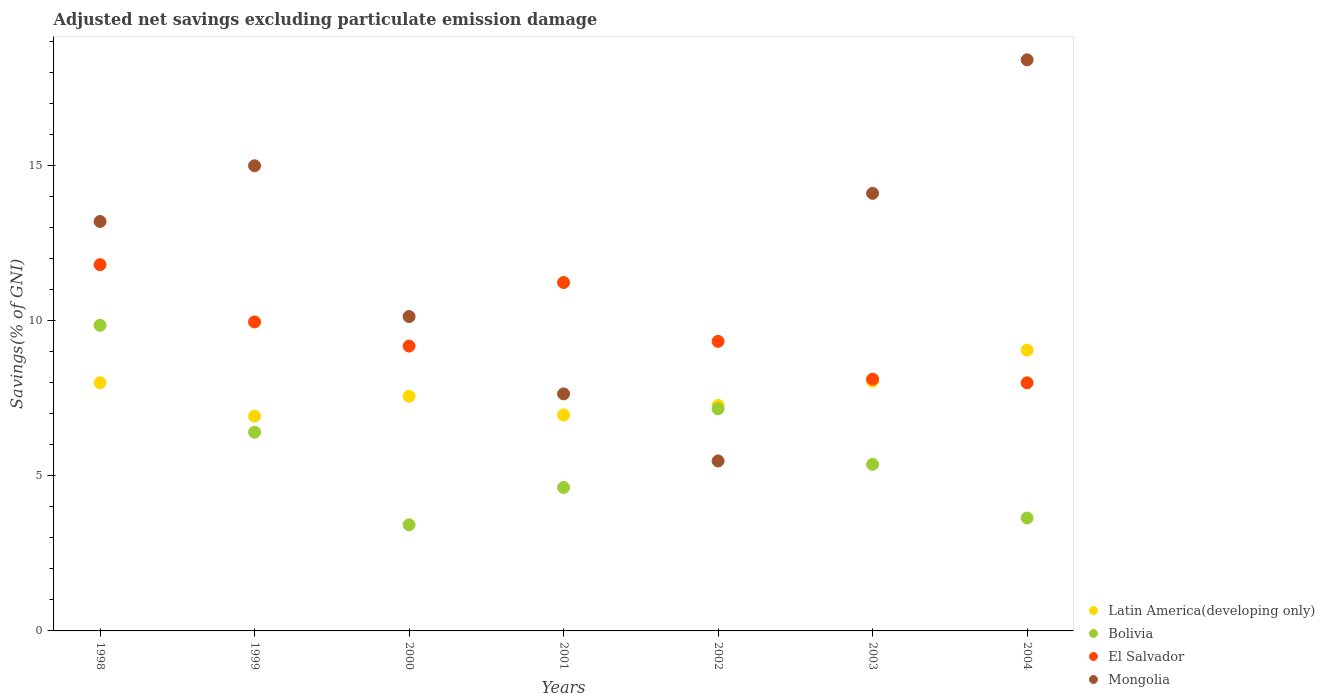How many different coloured dotlines are there?
Keep it short and to the point. 4. What is the adjusted net savings in Bolivia in 1998?
Provide a succinct answer. 9.85. Across all years, what is the maximum adjusted net savings in Bolivia?
Your response must be concise. 9.85. Across all years, what is the minimum adjusted net savings in Latin America(developing only)?
Offer a terse response. 6.92. In which year was the adjusted net savings in Bolivia maximum?
Provide a succinct answer. 1998. In which year was the adjusted net savings in Mongolia minimum?
Provide a succinct answer. 2002. What is the total adjusted net savings in Latin America(developing only) in the graph?
Provide a short and direct response. 53.78. What is the difference between the adjusted net savings in Bolivia in 1998 and that in 1999?
Offer a terse response. 3.44. What is the difference between the adjusted net savings in Bolivia in 1998 and the adjusted net savings in Mongolia in 2001?
Keep it short and to the point. 2.21. What is the average adjusted net savings in Mongolia per year?
Ensure brevity in your answer.  11.99. In the year 2003, what is the difference between the adjusted net savings in Latin America(developing only) and adjusted net savings in Mongolia?
Your answer should be very brief. -6.05. What is the ratio of the adjusted net savings in Latin America(developing only) in 2001 to that in 2004?
Offer a very short reply. 0.77. What is the difference between the highest and the second highest adjusted net savings in El Salvador?
Your answer should be very brief. 0.57. What is the difference between the highest and the lowest adjusted net savings in Mongolia?
Your answer should be compact. 12.92. Is it the case that in every year, the sum of the adjusted net savings in Bolivia and adjusted net savings in El Salvador  is greater than the sum of adjusted net savings in Mongolia and adjusted net savings in Latin America(developing only)?
Your answer should be compact. No. Is it the case that in every year, the sum of the adjusted net savings in Latin America(developing only) and adjusted net savings in Mongolia  is greater than the adjusted net savings in Bolivia?
Provide a short and direct response. Yes. Is the adjusted net savings in Bolivia strictly greater than the adjusted net savings in El Salvador over the years?
Provide a short and direct response. No. Is the adjusted net savings in El Salvador strictly less than the adjusted net savings in Bolivia over the years?
Ensure brevity in your answer.  No. What is the difference between two consecutive major ticks on the Y-axis?
Make the answer very short. 5. Are the values on the major ticks of Y-axis written in scientific E-notation?
Your response must be concise. No. Does the graph contain grids?
Your answer should be compact. No. How many legend labels are there?
Provide a succinct answer. 4. What is the title of the graph?
Your answer should be compact. Adjusted net savings excluding particulate emission damage. What is the label or title of the Y-axis?
Your answer should be very brief. Savings(% of GNI). What is the Savings(% of GNI) in Latin America(developing only) in 1998?
Your answer should be very brief. 7.99. What is the Savings(% of GNI) of Bolivia in 1998?
Provide a short and direct response. 9.85. What is the Savings(% of GNI) in El Salvador in 1998?
Make the answer very short. 11.8. What is the Savings(% of GNI) of Mongolia in 1998?
Your answer should be compact. 13.19. What is the Savings(% of GNI) in Latin America(developing only) in 1999?
Provide a succinct answer. 6.92. What is the Savings(% of GNI) in Bolivia in 1999?
Provide a short and direct response. 6.4. What is the Savings(% of GNI) of El Salvador in 1999?
Ensure brevity in your answer.  9.95. What is the Savings(% of GNI) in Mongolia in 1999?
Make the answer very short. 14.99. What is the Savings(% of GNI) in Latin America(developing only) in 2000?
Your answer should be compact. 7.56. What is the Savings(% of GNI) in Bolivia in 2000?
Offer a terse response. 3.42. What is the Savings(% of GNI) of El Salvador in 2000?
Your answer should be compact. 9.18. What is the Savings(% of GNI) in Mongolia in 2000?
Offer a terse response. 10.13. What is the Savings(% of GNI) in Latin America(developing only) in 2001?
Provide a short and direct response. 6.96. What is the Savings(% of GNI) in Bolivia in 2001?
Give a very brief answer. 4.62. What is the Savings(% of GNI) in El Salvador in 2001?
Your answer should be very brief. 11.22. What is the Savings(% of GNI) of Mongolia in 2001?
Your answer should be very brief. 7.64. What is the Savings(% of GNI) in Latin America(developing only) in 2002?
Offer a terse response. 7.27. What is the Savings(% of GNI) in Bolivia in 2002?
Ensure brevity in your answer.  7.16. What is the Savings(% of GNI) of El Salvador in 2002?
Keep it short and to the point. 9.33. What is the Savings(% of GNI) of Mongolia in 2002?
Your response must be concise. 5.47. What is the Savings(% of GNI) in Latin America(developing only) in 2003?
Offer a very short reply. 8.04. What is the Savings(% of GNI) of Bolivia in 2003?
Keep it short and to the point. 5.37. What is the Savings(% of GNI) in El Salvador in 2003?
Your answer should be very brief. 8.11. What is the Savings(% of GNI) of Mongolia in 2003?
Provide a succinct answer. 14.1. What is the Savings(% of GNI) in Latin America(developing only) in 2004?
Your response must be concise. 9.04. What is the Savings(% of GNI) in Bolivia in 2004?
Make the answer very short. 3.64. What is the Savings(% of GNI) in El Salvador in 2004?
Give a very brief answer. 7.99. What is the Savings(% of GNI) in Mongolia in 2004?
Your response must be concise. 18.4. Across all years, what is the maximum Savings(% of GNI) of Latin America(developing only)?
Ensure brevity in your answer.  9.04. Across all years, what is the maximum Savings(% of GNI) in Bolivia?
Make the answer very short. 9.85. Across all years, what is the maximum Savings(% of GNI) in El Salvador?
Provide a succinct answer. 11.8. Across all years, what is the maximum Savings(% of GNI) of Mongolia?
Keep it short and to the point. 18.4. Across all years, what is the minimum Savings(% of GNI) in Latin America(developing only)?
Provide a short and direct response. 6.92. Across all years, what is the minimum Savings(% of GNI) in Bolivia?
Your answer should be compact. 3.42. Across all years, what is the minimum Savings(% of GNI) of El Salvador?
Provide a succinct answer. 7.99. Across all years, what is the minimum Savings(% of GNI) of Mongolia?
Offer a terse response. 5.47. What is the total Savings(% of GNI) in Latin America(developing only) in the graph?
Your answer should be very brief. 53.78. What is the total Savings(% of GNI) of Bolivia in the graph?
Make the answer very short. 40.45. What is the total Savings(% of GNI) of El Salvador in the graph?
Offer a terse response. 67.58. What is the total Savings(% of GNI) in Mongolia in the graph?
Your response must be concise. 83.91. What is the difference between the Savings(% of GNI) of Latin America(developing only) in 1998 and that in 1999?
Keep it short and to the point. 1.07. What is the difference between the Savings(% of GNI) in Bolivia in 1998 and that in 1999?
Provide a short and direct response. 3.44. What is the difference between the Savings(% of GNI) of El Salvador in 1998 and that in 1999?
Your answer should be compact. 1.84. What is the difference between the Savings(% of GNI) in Mongolia in 1998 and that in 1999?
Ensure brevity in your answer.  -1.8. What is the difference between the Savings(% of GNI) of Latin America(developing only) in 1998 and that in 2000?
Keep it short and to the point. 0.43. What is the difference between the Savings(% of GNI) in Bolivia in 1998 and that in 2000?
Your answer should be very brief. 6.43. What is the difference between the Savings(% of GNI) of El Salvador in 1998 and that in 2000?
Provide a succinct answer. 2.62. What is the difference between the Savings(% of GNI) in Mongolia in 1998 and that in 2000?
Your answer should be very brief. 3.06. What is the difference between the Savings(% of GNI) in Latin America(developing only) in 1998 and that in 2001?
Your answer should be compact. 1.04. What is the difference between the Savings(% of GNI) in Bolivia in 1998 and that in 2001?
Keep it short and to the point. 5.22. What is the difference between the Savings(% of GNI) of El Salvador in 1998 and that in 2001?
Your answer should be compact. 0.57. What is the difference between the Savings(% of GNI) in Mongolia in 1998 and that in 2001?
Offer a very short reply. 5.55. What is the difference between the Savings(% of GNI) of Latin America(developing only) in 1998 and that in 2002?
Provide a short and direct response. 0.73. What is the difference between the Savings(% of GNI) of Bolivia in 1998 and that in 2002?
Your response must be concise. 2.69. What is the difference between the Savings(% of GNI) in El Salvador in 1998 and that in 2002?
Your response must be concise. 2.47. What is the difference between the Savings(% of GNI) in Mongolia in 1998 and that in 2002?
Provide a short and direct response. 7.71. What is the difference between the Savings(% of GNI) of Bolivia in 1998 and that in 2003?
Ensure brevity in your answer.  4.48. What is the difference between the Savings(% of GNI) of El Salvador in 1998 and that in 2003?
Your answer should be compact. 3.69. What is the difference between the Savings(% of GNI) of Mongolia in 1998 and that in 2003?
Make the answer very short. -0.91. What is the difference between the Savings(% of GNI) in Latin America(developing only) in 1998 and that in 2004?
Provide a succinct answer. -1.05. What is the difference between the Savings(% of GNI) of Bolivia in 1998 and that in 2004?
Offer a terse response. 6.21. What is the difference between the Savings(% of GNI) in El Salvador in 1998 and that in 2004?
Keep it short and to the point. 3.81. What is the difference between the Savings(% of GNI) of Mongolia in 1998 and that in 2004?
Ensure brevity in your answer.  -5.21. What is the difference between the Savings(% of GNI) in Latin America(developing only) in 1999 and that in 2000?
Provide a short and direct response. -0.64. What is the difference between the Savings(% of GNI) in Bolivia in 1999 and that in 2000?
Ensure brevity in your answer.  2.98. What is the difference between the Savings(% of GNI) in El Salvador in 1999 and that in 2000?
Provide a succinct answer. 0.78. What is the difference between the Savings(% of GNI) of Mongolia in 1999 and that in 2000?
Your answer should be compact. 4.86. What is the difference between the Savings(% of GNI) in Latin America(developing only) in 1999 and that in 2001?
Keep it short and to the point. -0.04. What is the difference between the Savings(% of GNI) in Bolivia in 1999 and that in 2001?
Offer a terse response. 1.78. What is the difference between the Savings(% of GNI) in El Salvador in 1999 and that in 2001?
Your response must be concise. -1.27. What is the difference between the Savings(% of GNI) of Mongolia in 1999 and that in 2001?
Offer a terse response. 7.35. What is the difference between the Savings(% of GNI) of Latin America(developing only) in 1999 and that in 2002?
Your answer should be compact. -0.35. What is the difference between the Savings(% of GNI) in Bolivia in 1999 and that in 2002?
Your answer should be very brief. -0.75. What is the difference between the Savings(% of GNI) of El Salvador in 1999 and that in 2002?
Make the answer very short. 0.63. What is the difference between the Savings(% of GNI) in Mongolia in 1999 and that in 2002?
Keep it short and to the point. 9.51. What is the difference between the Savings(% of GNI) in Latin America(developing only) in 1999 and that in 2003?
Give a very brief answer. -1.12. What is the difference between the Savings(% of GNI) in Bolivia in 1999 and that in 2003?
Ensure brevity in your answer.  1.04. What is the difference between the Savings(% of GNI) in El Salvador in 1999 and that in 2003?
Offer a very short reply. 1.84. What is the difference between the Savings(% of GNI) in Latin America(developing only) in 1999 and that in 2004?
Your answer should be very brief. -2.12. What is the difference between the Savings(% of GNI) of Bolivia in 1999 and that in 2004?
Offer a terse response. 2.77. What is the difference between the Savings(% of GNI) of El Salvador in 1999 and that in 2004?
Offer a very short reply. 1.96. What is the difference between the Savings(% of GNI) of Mongolia in 1999 and that in 2004?
Offer a terse response. -3.41. What is the difference between the Savings(% of GNI) of Latin America(developing only) in 2000 and that in 2001?
Offer a very short reply. 0.6. What is the difference between the Savings(% of GNI) in Bolivia in 2000 and that in 2001?
Your answer should be compact. -1.2. What is the difference between the Savings(% of GNI) of El Salvador in 2000 and that in 2001?
Make the answer very short. -2.05. What is the difference between the Savings(% of GNI) in Mongolia in 2000 and that in 2001?
Your answer should be compact. 2.49. What is the difference between the Savings(% of GNI) in Latin America(developing only) in 2000 and that in 2002?
Your answer should be compact. 0.29. What is the difference between the Savings(% of GNI) in Bolivia in 2000 and that in 2002?
Give a very brief answer. -3.74. What is the difference between the Savings(% of GNI) of El Salvador in 2000 and that in 2002?
Provide a short and direct response. -0.15. What is the difference between the Savings(% of GNI) of Mongolia in 2000 and that in 2002?
Your response must be concise. 4.65. What is the difference between the Savings(% of GNI) of Latin America(developing only) in 2000 and that in 2003?
Provide a short and direct response. -0.48. What is the difference between the Savings(% of GNI) of Bolivia in 2000 and that in 2003?
Make the answer very short. -1.95. What is the difference between the Savings(% of GNI) in El Salvador in 2000 and that in 2003?
Offer a terse response. 1.07. What is the difference between the Savings(% of GNI) of Mongolia in 2000 and that in 2003?
Your answer should be very brief. -3.97. What is the difference between the Savings(% of GNI) of Latin America(developing only) in 2000 and that in 2004?
Give a very brief answer. -1.48. What is the difference between the Savings(% of GNI) of Bolivia in 2000 and that in 2004?
Your answer should be compact. -0.22. What is the difference between the Savings(% of GNI) of El Salvador in 2000 and that in 2004?
Offer a terse response. 1.18. What is the difference between the Savings(% of GNI) in Mongolia in 2000 and that in 2004?
Make the answer very short. -8.27. What is the difference between the Savings(% of GNI) of Latin America(developing only) in 2001 and that in 2002?
Give a very brief answer. -0.31. What is the difference between the Savings(% of GNI) of Bolivia in 2001 and that in 2002?
Make the answer very short. -2.54. What is the difference between the Savings(% of GNI) in El Salvador in 2001 and that in 2002?
Provide a succinct answer. 1.9. What is the difference between the Savings(% of GNI) in Mongolia in 2001 and that in 2002?
Keep it short and to the point. 2.16. What is the difference between the Savings(% of GNI) in Latin America(developing only) in 2001 and that in 2003?
Provide a succinct answer. -1.09. What is the difference between the Savings(% of GNI) of Bolivia in 2001 and that in 2003?
Your answer should be compact. -0.74. What is the difference between the Savings(% of GNI) of El Salvador in 2001 and that in 2003?
Your answer should be compact. 3.11. What is the difference between the Savings(% of GNI) in Mongolia in 2001 and that in 2003?
Provide a succinct answer. -6.46. What is the difference between the Savings(% of GNI) of Latin America(developing only) in 2001 and that in 2004?
Make the answer very short. -2.09. What is the difference between the Savings(% of GNI) in Bolivia in 2001 and that in 2004?
Your answer should be compact. 0.98. What is the difference between the Savings(% of GNI) in El Salvador in 2001 and that in 2004?
Your answer should be very brief. 3.23. What is the difference between the Savings(% of GNI) in Mongolia in 2001 and that in 2004?
Provide a short and direct response. -10.76. What is the difference between the Savings(% of GNI) of Latin America(developing only) in 2002 and that in 2003?
Offer a very short reply. -0.78. What is the difference between the Savings(% of GNI) in Bolivia in 2002 and that in 2003?
Your response must be concise. 1.79. What is the difference between the Savings(% of GNI) in El Salvador in 2002 and that in 2003?
Offer a very short reply. 1.22. What is the difference between the Savings(% of GNI) in Mongolia in 2002 and that in 2003?
Your response must be concise. -8.62. What is the difference between the Savings(% of GNI) of Latin America(developing only) in 2002 and that in 2004?
Give a very brief answer. -1.78. What is the difference between the Savings(% of GNI) in Bolivia in 2002 and that in 2004?
Offer a terse response. 3.52. What is the difference between the Savings(% of GNI) in El Salvador in 2002 and that in 2004?
Your answer should be very brief. 1.34. What is the difference between the Savings(% of GNI) of Mongolia in 2002 and that in 2004?
Provide a short and direct response. -12.92. What is the difference between the Savings(% of GNI) of Latin America(developing only) in 2003 and that in 2004?
Keep it short and to the point. -1. What is the difference between the Savings(% of GNI) in Bolivia in 2003 and that in 2004?
Ensure brevity in your answer.  1.73. What is the difference between the Savings(% of GNI) in El Salvador in 2003 and that in 2004?
Provide a succinct answer. 0.12. What is the difference between the Savings(% of GNI) in Mongolia in 2003 and that in 2004?
Ensure brevity in your answer.  -4.3. What is the difference between the Savings(% of GNI) in Latin America(developing only) in 1998 and the Savings(% of GNI) in Bolivia in 1999?
Keep it short and to the point. 1.59. What is the difference between the Savings(% of GNI) of Latin America(developing only) in 1998 and the Savings(% of GNI) of El Salvador in 1999?
Make the answer very short. -1.96. What is the difference between the Savings(% of GNI) in Latin America(developing only) in 1998 and the Savings(% of GNI) in Mongolia in 1999?
Provide a short and direct response. -6.99. What is the difference between the Savings(% of GNI) in Bolivia in 1998 and the Savings(% of GNI) in El Salvador in 1999?
Your answer should be compact. -0.11. What is the difference between the Savings(% of GNI) in Bolivia in 1998 and the Savings(% of GNI) in Mongolia in 1999?
Your answer should be very brief. -5.14. What is the difference between the Savings(% of GNI) of El Salvador in 1998 and the Savings(% of GNI) of Mongolia in 1999?
Make the answer very short. -3.19. What is the difference between the Savings(% of GNI) of Latin America(developing only) in 1998 and the Savings(% of GNI) of Bolivia in 2000?
Provide a short and direct response. 4.57. What is the difference between the Savings(% of GNI) in Latin America(developing only) in 1998 and the Savings(% of GNI) in El Salvador in 2000?
Offer a terse response. -1.18. What is the difference between the Savings(% of GNI) in Latin America(developing only) in 1998 and the Savings(% of GNI) in Mongolia in 2000?
Your answer should be compact. -2.13. What is the difference between the Savings(% of GNI) in Bolivia in 1998 and the Savings(% of GNI) in El Salvador in 2000?
Your answer should be very brief. 0.67. What is the difference between the Savings(% of GNI) of Bolivia in 1998 and the Savings(% of GNI) of Mongolia in 2000?
Provide a short and direct response. -0.28. What is the difference between the Savings(% of GNI) of El Salvador in 1998 and the Savings(% of GNI) of Mongolia in 2000?
Keep it short and to the point. 1.67. What is the difference between the Savings(% of GNI) in Latin America(developing only) in 1998 and the Savings(% of GNI) in Bolivia in 2001?
Your answer should be very brief. 3.37. What is the difference between the Savings(% of GNI) in Latin America(developing only) in 1998 and the Savings(% of GNI) in El Salvador in 2001?
Offer a very short reply. -3.23. What is the difference between the Savings(% of GNI) of Latin America(developing only) in 1998 and the Savings(% of GNI) of Mongolia in 2001?
Make the answer very short. 0.36. What is the difference between the Savings(% of GNI) of Bolivia in 1998 and the Savings(% of GNI) of El Salvador in 2001?
Provide a short and direct response. -1.38. What is the difference between the Savings(% of GNI) in Bolivia in 1998 and the Savings(% of GNI) in Mongolia in 2001?
Make the answer very short. 2.21. What is the difference between the Savings(% of GNI) of El Salvador in 1998 and the Savings(% of GNI) of Mongolia in 2001?
Provide a succinct answer. 4.16. What is the difference between the Savings(% of GNI) in Latin America(developing only) in 1998 and the Savings(% of GNI) in Bolivia in 2002?
Your answer should be compact. 0.84. What is the difference between the Savings(% of GNI) of Latin America(developing only) in 1998 and the Savings(% of GNI) of El Salvador in 2002?
Ensure brevity in your answer.  -1.33. What is the difference between the Savings(% of GNI) in Latin America(developing only) in 1998 and the Savings(% of GNI) in Mongolia in 2002?
Offer a very short reply. 2.52. What is the difference between the Savings(% of GNI) of Bolivia in 1998 and the Savings(% of GNI) of El Salvador in 2002?
Provide a succinct answer. 0.52. What is the difference between the Savings(% of GNI) in Bolivia in 1998 and the Savings(% of GNI) in Mongolia in 2002?
Provide a succinct answer. 4.37. What is the difference between the Savings(% of GNI) in El Salvador in 1998 and the Savings(% of GNI) in Mongolia in 2002?
Ensure brevity in your answer.  6.32. What is the difference between the Savings(% of GNI) in Latin America(developing only) in 1998 and the Savings(% of GNI) in Bolivia in 2003?
Give a very brief answer. 2.63. What is the difference between the Savings(% of GNI) in Latin America(developing only) in 1998 and the Savings(% of GNI) in El Salvador in 2003?
Offer a terse response. -0.12. What is the difference between the Savings(% of GNI) in Latin America(developing only) in 1998 and the Savings(% of GNI) in Mongolia in 2003?
Give a very brief answer. -6.1. What is the difference between the Savings(% of GNI) of Bolivia in 1998 and the Savings(% of GNI) of El Salvador in 2003?
Provide a short and direct response. 1.73. What is the difference between the Savings(% of GNI) in Bolivia in 1998 and the Savings(% of GNI) in Mongolia in 2003?
Make the answer very short. -4.25. What is the difference between the Savings(% of GNI) in El Salvador in 1998 and the Savings(% of GNI) in Mongolia in 2003?
Provide a succinct answer. -2.3. What is the difference between the Savings(% of GNI) in Latin America(developing only) in 1998 and the Savings(% of GNI) in Bolivia in 2004?
Ensure brevity in your answer.  4.36. What is the difference between the Savings(% of GNI) in Latin America(developing only) in 1998 and the Savings(% of GNI) in El Salvador in 2004?
Offer a very short reply. 0. What is the difference between the Savings(% of GNI) in Latin America(developing only) in 1998 and the Savings(% of GNI) in Mongolia in 2004?
Provide a short and direct response. -10.4. What is the difference between the Savings(% of GNI) of Bolivia in 1998 and the Savings(% of GNI) of El Salvador in 2004?
Offer a terse response. 1.85. What is the difference between the Savings(% of GNI) in Bolivia in 1998 and the Savings(% of GNI) in Mongolia in 2004?
Make the answer very short. -8.55. What is the difference between the Savings(% of GNI) of El Salvador in 1998 and the Savings(% of GNI) of Mongolia in 2004?
Your answer should be compact. -6.6. What is the difference between the Savings(% of GNI) of Latin America(developing only) in 1999 and the Savings(% of GNI) of Bolivia in 2000?
Your response must be concise. 3.5. What is the difference between the Savings(% of GNI) in Latin America(developing only) in 1999 and the Savings(% of GNI) in El Salvador in 2000?
Keep it short and to the point. -2.26. What is the difference between the Savings(% of GNI) in Latin America(developing only) in 1999 and the Savings(% of GNI) in Mongolia in 2000?
Give a very brief answer. -3.21. What is the difference between the Savings(% of GNI) of Bolivia in 1999 and the Savings(% of GNI) of El Salvador in 2000?
Make the answer very short. -2.77. What is the difference between the Savings(% of GNI) of Bolivia in 1999 and the Savings(% of GNI) of Mongolia in 2000?
Your answer should be very brief. -3.73. What is the difference between the Savings(% of GNI) of El Salvador in 1999 and the Savings(% of GNI) of Mongolia in 2000?
Give a very brief answer. -0.17. What is the difference between the Savings(% of GNI) of Latin America(developing only) in 1999 and the Savings(% of GNI) of Bolivia in 2001?
Keep it short and to the point. 2.3. What is the difference between the Savings(% of GNI) in Latin America(developing only) in 1999 and the Savings(% of GNI) in El Salvador in 2001?
Ensure brevity in your answer.  -4.3. What is the difference between the Savings(% of GNI) of Latin America(developing only) in 1999 and the Savings(% of GNI) of Mongolia in 2001?
Give a very brief answer. -0.72. What is the difference between the Savings(% of GNI) in Bolivia in 1999 and the Savings(% of GNI) in El Salvador in 2001?
Give a very brief answer. -4.82. What is the difference between the Savings(% of GNI) of Bolivia in 1999 and the Savings(% of GNI) of Mongolia in 2001?
Your response must be concise. -1.23. What is the difference between the Savings(% of GNI) of El Salvador in 1999 and the Savings(% of GNI) of Mongolia in 2001?
Provide a succinct answer. 2.32. What is the difference between the Savings(% of GNI) of Latin America(developing only) in 1999 and the Savings(% of GNI) of Bolivia in 2002?
Your response must be concise. -0.24. What is the difference between the Savings(% of GNI) of Latin America(developing only) in 1999 and the Savings(% of GNI) of El Salvador in 2002?
Make the answer very short. -2.41. What is the difference between the Savings(% of GNI) of Latin America(developing only) in 1999 and the Savings(% of GNI) of Mongolia in 2002?
Ensure brevity in your answer.  1.44. What is the difference between the Savings(% of GNI) of Bolivia in 1999 and the Savings(% of GNI) of El Salvador in 2002?
Your answer should be compact. -2.93. What is the difference between the Savings(% of GNI) in Bolivia in 1999 and the Savings(% of GNI) in Mongolia in 2002?
Provide a succinct answer. 0.93. What is the difference between the Savings(% of GNI) in El Salvador in 1999 and the Savings(% of GNI) in Mongolia in 2002?
Provide a short and direct response. 4.48. What is the difference between the Savings(% of GNI) in Latin America(developing only) in 1999 and the Savings(% of GNI) in Bolivia in 2003?
Provide a succinct answer. 1.55. What is the difference between the Savings(% of GNI) in Latin America(developing only) in 1999 and the Savings(% of GNI) in El Salvador in 2003?
Ensure brevity in your answer.  -1.19. What is the difference between the Savings(% of GNI) in Latin America(developing only) in 1999 and the Savings(% of GNI) in Mongolia in 2003?
Ensure brevity in your answer.  -7.18. What is the difference between the Savings(% of GNI) of Bolivia in 1999 and the Savings(% of GNI) of El Salvador in 2003?
Offer a terse response. -1.71. What is the difference between the Savings(% of GNI) in Bolivia in 1999 and the Savings(% of GNI) in Mongolia in 2003?
Keep it short and to the point. -7.69. What is the difference between the Savings(% of GNI) in El Salvador in 1999 and the Savings(% of GNI) in Mongolia in 2003?
Your answer should be very brief. -4.14. What is the difference between the Savings(% of GNI) in Latin America(developing only) in 1999 and the Savings(% of GNI) in Bolivia in 2004?
Give a very brief answer. 3.28. What is the difference between the Savings(% of GNI) in Latin America(developing only) in 1999 and the Savings(% of GNI) in El Salvador in 2004?
Provide a succinct answer. -1.07. What is the difference between the Savings(% of GNI) in Latin America(developing only) in 1999 and the Savings(% of GNI) in Mongolia in 2004?
Provide a short and direct response. -11.48. What is the difference between the Savings(% of GNI) in Bolivia in 1999 and the Savings(% of GNI) in El Salvador in 2004?
Give a very brief answer. -1.59. What is the difference between the Savings(% of GNI) of Bolivia in 1999 and the Savings(% of GNI) of Mongolia in 2004?
Your answer should be compact. -12. What is the difference between the Savings(% of GNI) in El Salvador in 1999 and the Savings(% of GNI) in Mongolia in 2004?
Your response must be concise. -8.44. What is the difference between the Savings(% of GNI) in Latin America(developing only) in 2000 and the Savings(% of GNI) in Bolivia in 2001?
Your answer should be very brief. 2.94. What is the difference between the Savings(% of GNI) of Latin America(developing only) in 2000 and the Savings(% of GNI) of El Salvador in 2001?
Ensure brevity in your answer.  -3.67. What is the difference between the Savings(% of GNI) in Latin America(developing only) in 2000 and the Savings(% of GNI) in Mongolia in 2001?
Your response must be concise. -0.08. What is the difference between the Savings(% of GNI) in Bolivia in 2000 and the Savings(% of GNI) in El Salvador in 2001?
Provide a succinct answer. -7.81. What is the difference between the Savings(% of GNI) in Bolivia in 2000 and the Savings(% of GNI) in Mongolia in 2001?
Give a very brief answer. -4.22. What is the difference between the Savings(% of GNI) of El Salvador in 2000 and the Savings(% of GNI) of Mongolia in 2001?
Provide a succinct answer. 1.54. What is the difference between the Savings(% of GNI) in Latin America(developing only) in 2000 and the Savings(% of GNI) in Bolivia in 2002?
Your answer should be very brief. 0.4. What is the difference between the Savings(% of GNI) of Latin America(developing only) in 2000 and the Savings(% of GNI) of El Salvador in 2002?
Provide a succinct answer. -1.77. What is the difference between the Savings(% of GNI) in Latin America(developing only) in 2000 and the Savings(% of GNI) in Mongolia in 2002?
Keep it short and to the point. 2.08. What is the difference between the Savings(% of GNI) of Bolivia in 2000 and the Savings(% of GNI) of El Salvador in 2002?
Your response must be concise. -5.91. What is the difference between the Savings(% of GNI) in Bolivia in 2000 and the Savings(% of GNI) in Mongolia in 2002?
Offer a terse response. -2.06. What is the difference between the Savings(% of GNI) of El Salvador in 2000 and the Savings(% of GNI) of Mongolia in 2002?
Offer a very short reply. 3.7. What is the difference between the Savings(% of GNI) in Latin America(developing only) in 2000 and the Savings(% of GNI) in Bolivia in 2003?
Provide a short and direct response. 2.19. What is the difference between the Savings(% of GNI) in Latin America(developing only) in 2000 and the Savings(% of GNI) in El Salvador in 2003?
Your answer should be compact. -0.55. What is the difference between the Savings(% of GNI) in Latin America(developing only) in 2000 and the Savings(% of GNI) in Mongolia in 2003?
Make the answer very short. -6.54. What is the difference between the Savings(% of GNI) of Bolivia in 2000 and the Savings(% of GNI) of El Salvador in 2003?
Offer a terse response. -4.69. What is the difference between the Savings(% of GNI) of Bolivia in 2000 and the Savings(% of GNI) of Mongolia in 2003?
Your response must be concise. -10.68. What is the difference between the Savings(% of GNI) in El Salvador in 2000 and the Savings(% of GNI) in Mongolia in 2003?
Offer a very short reply. -4.92. What is the difference between the Savings(% of GNI) in Latin America(developing only) in 2000 and the Savings(% of GNI) in Bolivia in 2004?
Offer a terse response. 3.92. What is the difference between the Savings(% of GNI) of Latin America(developing only) in 2000 and the Savings(% of GNI) of El Salvador in 2004?
Your response must be concise. -0.43. What is the difference between the Savings(% of GNI) in Latin America(developing only) in 2000 and the Savings(% of GNI) in Mongolia in 2004?
Offer a very short reply. -10.84. What is the difference between the Savings(% of GNI) of Bolivia in 2000 and the Savings(% of GNI) of El Salvador in 2004?
Offer a very short reply. -4.57. What is the difference between the Savings(% of GNI) in Bolivia in 2000 and the Savings(% of GNI) in Mongolia in 2004?
Provide a short and direct response. -14.98. What is the difference between the Savings(% of GNI) in El Salvador in 2000 and the Savings(% of GNI) in Mongolia in 2004?
Provide a short and direct response. -9.22. What is the difference between the Savings(% of GNI) in Latin America(developing only) in 2001 and the Savings(% of GNI) in Bolivia in 2002?
Your answer should be compact. -0.2. What is the difference between the Savings(% of GNI) of Latin America(developing only) in 2001 and the Savings(% of GNI) of El Salvador in 2002?
Give a very brief answer. -2.37. What is the difference between the Savings(% of GNI) in Latin America(developing only) in 2001 and the Savings(% of GNI) in Mongolia in 2002?
Offer a terse response. 1.48. What is the difference between the Savings(% of GNI) of Bolivia in 2001 and the Savings(% of GNI) of El Salvador in 2002?
Give a very brief answer. -4.71. What is the difference between the Savings(% of GNI) in Bolivia in 2001 and the Savings(% of GNI) in Mongolia in 2002?
Offer a terse response. -0.85. What is the difference between the Savings(% of GNI) of El Salvador in 2001 and the Savings(% of GNI) of Mongolia in 2002?
Provide a short and direct response. 5.75. What is the difference between the Savings(% of GNI) of Latin America(developing only) in 2001 and the Savings(% of GNI) of Bolivia in 2003?
Provide a short and direct response. 1.59. What is the difference between the Savings(% of GNI) in Latin America(developing only) in 2001 and the Savings(% of GNI) in El Salvador in 2003?
Offer a very short reply. -1.15. What is the difference between the Savings(% of GNI) of Latin America(developing only) in 2001 and the Savings(% of GNI) of Mongolia in 2003?
Give a very brief answer. -7.14. What is the difference between the Savings(% of GNI) in Bolivia in 2001 and the Savings(% of GNI) in El Salvador in 2003?
Your response must be concise. -3.49. What is the difference between the Savings(% of GNI) of Bolivia in 2001 and the Savings(% of GNI) of Mongolia in 2003?
Keep it short and to the point. -9.48. What is the difference between the Savings(% of GNI) in El Salvador in 2001 and the Savings(% of GNI) in Mongolia in 2003?
Provide a succinct answer. -2.87. What is the difference between the Savings(% of GNI) of Latin America(developing only) in 2001 and the Savings(% of GNI) of Bolivia in 2004?
Provide a succinct answer. 3.32. What is the difference between the Savings(% of GNI) in Latin America(developing only) in 2001 and the Savings(% of GNI) in El Salvador in 2004?
Keep it short and to the point. -1.03. What is the difference between the Savings(% of GNI) of Latin America(developing only) in 2001 and the Savings(% of GNI) of Mongolia in 2004?
Provide a short and direct response. -11.44. What is the difference between the Savings(% of GNI) in Bolivia in 2001 and the Savings(% of GNI) in El Salvador in 2004?
Provide a short and direct response. -3.37. What is the difference between the Savings(% of GNI) of Bolivia in 2001 and the Savings(% of GNI) of Mongolia in 2004?
Make the answer very short. -13.78. What is the difference between the Savings(% of GNI) in El Salvador in 2001 and the Savings(% of GNI) in Mongolia in 2004?
Offer a terse response. -7.17. What is the difference between the Savings(% of GNI) in Latin America(developing only) in 2002 and the Savings(% of GNI) in Bolivia in 2003?
Provide a succinct answer. 1.9. What is the difference between the Savings(% of GNI) in Latin America(developing only) in 2002 and the Savings(% of GNI) in El Salvador in 2003?
Give a very brief answer. -0.84. What is the difference between the Savings(% of GNI) in Latin America(developing only) in 2002 and the Savings(% of GNI) in Mongolia in 2003?
Ensure brevity in your answer.  -6.83. What is the difference between the Savings(% of GNI) of Bolivia in 2002 and the Savings(% of GNI) of El Salvador in 2003?
Your answer should be compact. -0.95. What is the difference between the Savings(% of GNI) of Bolivia in 2002 and the Savings(% of GNI) of Mongolia in 2003?
Offer a very short reply. -6.94. What is the difference between the Savings(% of GNI) in El Salvador in 2002 and the Savings(% of GNI) in Mongolia in 2003?
Ensure brevity in your answer.  -4.77. What is the difference between the Savings(% of GNI) of Latin America(developing only) in 2002 and the Savings(% of GNI) of Bolivia in 2004?
Your answer should be very brief. 3.63. What is the difference between the Savings(% of GNI) in Latin America(developing only) in 2002 and the Savings(% of GNI) in El Salvador in 2004?
Offer a very short reply. -0.73. What is the difference between the Savings(% of GNI) in Latin America(developing only) in 2002 and the Savings(% of GNI) in Mongolia in 2004?
Provide a succinct answer. -11.13. What is the difference between the Savings(% of GNI) of Bolivia in 2002 and the Savings(% of GNI) of El Salvador in 2004?
Provide a short and direct response. -0.84. What is the difference between the Savings(% of GNI) in Bolivia in 2002 and the Savings(% of GNI) in Mongolia in 2004?
Offer a very short reply. -11.24. What is the difference between the Savings(% of GNI) in El Salvador in 2002 and the Savings(% of GNI) in Mongolia in 2004?
Offer a terse response. -9.07. What is the difference between the Savings(% of GNI) of Latin America(developing only) in 2003 and the Savings(% of GNI) of Bolivia in 2004?
Ensure brevity in your answer.  4.41. What is the difference between the Savings(% of GNI) of Latin America(developing only) in 2003 and the Savings(% of GNI) of El Salvador in 2004?
Your response must be concise. 0.05. What is the difference between the Savings(% of GNI) in Latin America(developing only) in 2003 and the Savings(% of GNI) in Mongolia in 2004?
Give a very brief answer. -10.35. What is the difference between the Savings(% of GNI) in Bolivia in 2003 and the Savings(% of GNI) in El Salvador in 2004?
Give a very brief answer. -2.63. What is the difference between the Savings(% of GNI) of Bolivia in 2003 and the Savings(% of GNI) of Mongolia in 2004?
Offer a very short reply. -13.03. What is the difference between the Savings(% of GNI) in El Salvador in 2003 and the Savings(% of GNI) in Mongolia in 2004?
Give a very brief answer. -10.29. What is the average Savings(% of GNI) in Latin America(developing only) per year?
Ensure brevity in your answer.  7.68. What is the average Savings(% of GNI) in Bolivia per year?
Offer a very short reply. 5.78. What is the average Savings(% of GNI) of El Salvador per year?
Provide a short and direct response. 9.65. What is the average Savings(% of GNI) of Mongolia per year?
Offer a very short reply. 11.99. In the year 1998, what is the difference between the Savings(% of GNI) in Latin America(developing only) and Savings(% of GNI) in Bolivia?
Your response must be concise. -1.85. In the year 1998, what is the difference between the Savings(% of GNI) of Latin America(developing only) and Savings(% of GNI) of El Salvador?
Give a very brief answer. -3.8. In the year 1998, what is the difference between the Savings(% of GNI) of Latin America(developing only) and Savings(% of GNI) of Mongolia?
Offer a terse response. -5.2. In the year 1998, what is the difference between the Savings(% of GNI) of Bolivia and Savings(% of GNI) of El Salvador?
Offer a terse response. -1.95. In the year 1998, what is the difference between the Savings(% of GNI) of Bolivia and Savings(% of GNI) of Mongolia?
Offer a very short reply. -3.34. In the year 1998, what is the difference between the Savings(% of GNI) in El Salvador and Savings(% of GNI) in Mongolia?
Your response must be concise. -1.39. In the year 1999, what is the difference between the Savings(% of GNI) in Latin America(developing only) and Savings(% of GNI) in Bolivia?
Ensure brevity in your answer.  0.52. In the year 1999, what is the difference between the Savings(% of GNI) of Latin America(developing only) and Savings(% of GNI) of El Salvador?
Keep it short and to the point. -3.03. In the year 1999, what is the difference between the Savings(% of GNI) of Latin America(developing only) and Savings(% of GNI) of Mongolia?
Your response must be concise. -8.07. In the year 1999, what is the difference between the Savings(% of GNI) in Bolivia and Savings(% of GNI) in El Salvador?
Keep it short and to the point. -3.55. In the year 1999, what is the difference between the Savings(% of GNI) of Bolivia and Savings(% of GNI) of Mongolia?
Provide a short and direct response. -8.58. In the year 1999, what is the difference between the Savings(% of GNI) in El Salvador and Savings(% of GNI) in Mongolia?
Keep it short and to the point. -5.03. In the year 2000, what is the difference between the Savings(% of GNI) in Latin America(developing only) and Savings(% of GNI) in Bolivia?
Ensure brevity in your answer.  4.14. In the year 2000, what is the difference between the Savings(% of GNI) of Latin America(developing only) and Savings(% of GNI) of El Salvador?
Ensure brevity in your answer.  -1.62. In the year 2000, what is the difference between the Savings(% of GNI) of Latin America(developing only) and Savings(% of GNI) of Mongolia?
Provide a short and direct response. -2.57. In the year 2000, what is the difference between the Savings(% of GNI) in Bolivia and Savings(% of GNI) in El Salvador?
Give a very brief answer. -5.76. In the year 2000, what is the difference between the Savings(% of GNI) of Bolivia and Savings(% of GNI) of Mongolia?
Your answer should be very brief. -6.71. In the year 2000, what is the difference between the Savings(% of GNI) of El Salvador and Savings(% of GNI) of Mongolia?
Your answer should be very brief. -0.95. In the year 2001, what is the difference between the Savings(% of GNI) of Latin America(developing only) and Savings(% of GNI) of Bolivia?
Provide a short and direct response. 2.34. In the year 2001, what is the difference between the Savings(% of GNI) of Latin America(developing only) and Savings(% of GNI) of El Salvador?
Your response must be concise. -4.27. In the year 2001, what is the difference between the Savings(% of GNI) in Latin America(developing only) and Savings(% of GNI) in Mongolia?
Offer a terse response. -0.68. In the year 2001, what is the difference between the Savings(% of GNI) in Bolivia and Savings(% of GNI) in El Salvador?
Ensure brevity in your answer.  -6.6. In the year 2001, what is the difference between the Savings(% of GNI) of Bolivia and Savings(% of GNI) of Mongolia?
Provide a succinct answer. -3.02. In the year 2001, what is the difference between the Savings(% of GNI) of El Salvador and Savings(% of GNI) of Mongolia?
Keep it short and to the point. 3.59. In the year 2002, what is the difference between the Savings(% of GNI) in Latin America(developing only) and Savings(% of GNI) in Bolivia?
Ensure brevity in your answer.  0.11. In the year 2002, what is the difference between the Savings(% of GNI) of Latin America(developing only) and Savings(% of GNI) of El Salvador?
Provide a short and direct response. -2.06. In the year 2002, what is the difference between the Savings(% of GNI) of Latin America(developing only) and Savings(% of GNI) of Mongolia?
Your answer should be very brief. 1.79. In the year 2002, what is the difference between the Savings(% of GNI) in Bolivia and Savings(% of GNI) in El Salvador?
Keep it short and to the point. -2.17. In the year 2002, what is the difference between the Savings(% of GNI) of Bolivia and Savings(% of GNI) of Mongolia?
Offer a terse response. 1.68. In the year 2002, what is the difference between the Savings(% of GNI) of El Salvador and Savings(% of GNI) of Mongolia?
Give a very brief answer. 3.85. In the year 2003, what is the difference between the Savings(% of GNI) in Latin America(developing only) and Savings(% of GNI) in Bolivia?
Keep it short and to the point. 2.68. In the year 2003, what is the difference between the Savings(% of GNI) of Latin America(developing only) and Savings(% of GNI) of El Salvador?
Provide a short and direct response. -0.07. In the year 2003, what is the difference between the Savings(% of GNI) of Latin America(developing only) and Savings(% of GNI) of Mongolia?
Offer a terse response. -6.05. In the year 2003, what is the difference between the Savings(% of GNI) in Bolivia and Savings(% of GNI) in El Salvador?
Your response must be concise. -2.74. In the year 2003, what is the difference between the Savings(% of GNI) in Bolivia and Savings(% of GNI) in Mongolia?
Your answer should be compact. -8.73. In the year 2003, what is the difference between the Savings(% of GNI) of El Salvador and Savings(% of GNI) of Mongolia?
Your response must be concise. -5.99. In the year 2004, what is the difference between the Savings(% of GNI) in Latin America(developing only) and Savings(% of GNI) in Bolivia?
Your response must be concise. 5.41. In the year 2004, what is the difference between the Savings(% of GNI) of Latin America(developing only) and Savings(% of GNI) of El Salvador?
Your response must be concise. 1.05. In the year 2004, what is the difference between the Savings(% of GNI) of Latin America(developing only) and Savings(% of GNI) of Mongolia?
Provide a short and direct response. -9.35. In the year 2004, what is the difference between the Savings(% of GNI) in Bolivia and Savings(% of GNI) in El Salvador?
Provide a succinct answer. -4.36. In the year 2004, what is the difference between the Savings(% of GNI) in Bolivia and Savings(% of GNI) in Mongolia?
Provide a short and direct response. -14.76. In the year 2004, what is the difference between the Savings(% of GNI) of El Salvador and Savings(% of GNI) of Mongolia?
Your response must be concise. -10.41. What is the ratio of the Savings(% of GNI) of Latin America(developing only) in 1998 to that in 1999?
Provide a short and direct response. 1.16. What is the ratio of the Savings(% of GNI) in Bolivia in 1998 to that in 1999?
Provide a succinct answer. 1.54. What is the ratio of the Savings(% of GNI) of El Salvador in 1998 to that in 1999?
Offer a very short reply. 1.19. What is the ratio of the Savings(% of GNI) of Mongolia in 1998 to that in 1999?
Offer a very short reply. 0.88. What is the ratio of the Savings(% of GNI) of Latin America(developing only) in 1998 to that in 2000?
Provide a succinct answer. 1.06. What is the ratio of the Savings(% of GNI) in Bolivia in 1998 to that in 2000?
Offer a very short reply. 2.88. What is the ratio of the Savings(% of GNI) of El Salvador in 1998 to that in 2000?
Make the answer very short. 1.29. What is the ratio of the Savings(% of GNI) in Mongolia in 1998 to that in 2000?
Offer a very short reply. 1.3. What is the ratio of the Savings(% of GNI) of Latin America(developing only) in 1998 to that in 2001?
Keep it short and to the point. 1.15. What is the ratio of the Savings(% of GNI) of Bolivia in 1998 to that in 2001?
Provide a short and direct response. 2.13. What is the ratio of the Savings(% of GNI) in El Salvador in 1998 to that in 2001?
Provide a succinct answer. 1.05. What is the ratio of the Savings(% of GNI) of Mongolia in 1998 to that in 2001?
Make the answer very short. 1.73. What is the ratio of the Savings(% of GNI) of Latin America(developing only) in 1998 to that in 2002?
Your response must be concise. 1.1. What is the ratio of the Savings(% of GNI) of Bolivia in 1998 to that in 2002?
Offer a very short reply. 1.38. What is the ratio of the Savings(% of GNI) in El Salvador in 1998 to that in 2002?
Provide a short and direct response. 1.26. What is the ratio of the Savings(% of GNI) in Mongolia in 1998 to that in 2002?
Keep it short and to the point. 2.41. What is the ratio of the Savings(% of GNI) in Latin America(developing only) in 1998 to that in 2003?
Make the answer very short. 0.99. What is the ratio of the Savings(% of GNI) of Bolivia in 1998 to that in 2003?
Offer a very short reply. 1.83. What is the ratio of the Savings(% of GNI) in El Salvador in 1998 to that in 2003?
Provide a succinct answer. 1.45. What is the ratio of the Savings(% of GNI) of Mongolia in 1998 to that in 2003?
Your answer should be compact. 0.94. What is the ratio of the Savings(% of GNI) of Latin America(developing only) in 1998 to that in 2004?
Give a very brief answer. 0.88. What is the ratio of the Savings(% of GNI) in Bolivia in 1998 to that in 2004?
Ensure brevity in your answer.  2.71. What is the ratio of the Savings(% of GNI) in El Salvador in 1998 to that in 2004?
Make the answer very short. 1.48. What is the ratio of the Savings(% of GNI) of Mongolia in 1998 to that in 2004?
Ensure brevity in your answer.  0.72. What is the ratio of the Savings(% of GNI) in Latin America(developing only) in 1999 to that in 2000?
Offer a terse response. 0.92. What is the ratio of the Savings(% of GNI) in Bolivia in 1999 to that in 2000?
Your response must be concise. 1.87. What is the ratio of the Savings(% of GNI) in El Salvador in 1999 to that in 2000?
Your answer should be very brief. 1.08. What is the ratio of the Savings(% of GNI) of Mongolia in 1999 to that in 2000?
Offer a very short reply. 1.48. What is the ratio of the Savings(% of GNI) in Latin America(developing only) in 1999 to that in 2001?
Offer a very short reply. 0.99. What is the ratio of the Savings(% of GNI) in Bolivia in 1999 to that in 2001?
Keep it short and to the point. 1.39. What is the ratio of the Savings(% of GNI) of El Salvador in 1999 to that in 2001?
Provide a succinct answer. 0.89. What is the ratio of the Savings(% of GNI) of Mongolia in 1999 to that in 2001?
Keep it short and to the point. 1.96. What is the ratio of the Savings(% of GNI) of Latin America(developing only) in 1999 to that in 2002?
Your answer should be compact. 0.95. What is the ratio of the Savings(% of GNI) in Bolivia in 1999 to that in 2002?
Your response must be concise. 0.89. What is the ratio of the Savings(% of GNI) of El Salvador in 1999 to that in 2002?
Provide a succinct answer. 1.07. What is the ratio of the Savings(% of GNI) of Mongolia in 1999 to that in 2002?
Your answer should be compact. 2.74. What is the ratio of the Savings(% of GNI) of Latin America(developing only) in 1999 to that in 2003?
Offer a very short reply. 0.86. What is the ratio of the Savings(% of GNI) in Bolivia in 1999 to that in 2003?
Your answer should be very brief. 1.19. What is the ratio of the Savings(% of GNI) in El Salvador in 1999 to that in 2003?
Offer a very short reply. 1.23. What is the ratio of the Savings(% of GNI) in Mongolia in 1999 to that in 2003?
Your answer should be very brief. 1.06. What is the ratio of the Savings(% of GNI) in Latin America(developing only) in 1999 to that in 2004?
Provide a short and direct response. 0.77. What is the ratio of the Savings(% of GNI) of Bolivia in 1999 to that in 2004?
Your answer should be compact. 1.76. What is the ratio of the Savings(% of GNI) in El Salvador in 1999 to that in 2004?
Offer a very short reply. 1.25. What is the ratio of the Savings(% of GNI) of Mongolia in 1999 to that in 2004?
Provide a succinct answer. 0.81. What is the ratio of the Savings(% of GNI) of Latin America(developing only) in 2000 to that in 2001?
Provide a succinct answer. 1.09. What is the ratio of the Savings(% of GNI) in Bolivia in 2000 to that in 2001?
Your response must be concise. 0.74. What is the ratio of the Savings(% of GNI) of El Salvador in 2000 to that in 2001?
Keep it short and to the point. 0.82. What is the ratio of the Savings(% of GNI) in Mongolia in 2000 to that in 2001?
Your response must be concise. 1.33. What is the ratio of the Savings(% of GNI) of Latin America(developing only) in 2000 to that in 2002?
Provide a short and direct response. 1.04. What is the ratio of the Savings(% of GNI) in Bolivia in 2000 to that in 2002?
Your response must be concise. 0.48. What is the ratio of the Savings(% of GNI) in El Salvador in 2000 to that in 2002?
Your response must be concise. 0.98. What is the ratio of the Savings(% of GNI) of Mongolia in 2000 to that in 2002?
Offer a very short reply. 1.85. What is the ratio of the Savings(% of GNI) of Latin America(developing only) in 2000 to that in 2003?
Ensure brevity in your answer.  0.94. What is the ratio of the Savings(% of GNI) of Bolivia in 2000 to that in 2003?
Provide a short and direct response. 0.64. What is the ratio of the Savings(% of GNI) in El Salvador in 2000 to that in 2003?
Ensure brevity in your answer.  1.13. What is the ratio of the Savings(% of GNI) in Mongolia in 2000 to that in 2003?
Give a very brief answer. 0.72. What is the ratio of the Savings(% of GNI) in Latin America(developing only) in 2000 to that in 2004?
Provide a short and direct response. 0.84. What is the ratio of the Savings(% of GNI) in Bolivia in 2000 to that in 2004?
Offer a very short reply. 0.94. What is the ratio of the Savings(% of GNI) in El Salvador in 2000 to that in 2004?
Provide a succinct answer. 1.15. What is the ratio of the Savings(% of GNI) in Mongolia in 2000 to that in 2004?
Provide a succinct answer. 0.55. What is the ratio of the Savings(% of GNI) in Latin America(developing only) in 2001 to that in 2002?
Give a very brief answer. 0.96. What is the ratio of the Savings(% of GNI) of Bolivia in 2001 to that in 2002?
Keep it short and to the point. 0.65. What is the ratio of the Savings(% of GNI) in El Salvador in 2001 to that in 2002?
Your answer should be compact. 1.2. What is the ratio of the Savings(% of GNI) of Mongolia in 2001 to that in 2002?
Your answer should be very brief. 1.39. What is the ratio of the Savings(% of GNI) in Latin America(developing only) in 2001 to that in 2003?
Ensure brevity in your answer.  0.86. What is the ratio of the Savings(% of GNI) of Bolivia in 2001 to that in 2003?
Your answer should be very brief. 0.86. What is the ratio of the Savings(% of GNI) in El Salvador in 2001 to that in 2003?
Offer a very short reply. 1.38. What is the ratio of the Savings(% of GNI) of Mongolia in 2001 to that in 2003?
Provide a short and direct response. 0.54. What is the ratio of the Savings(% of GNI) in Latin America(developing only) in 2001 to that in 2004?
Your answer should be compact. 0.77. What is the ratio of the Savings(% of GNI) of Bolivia in 2001 to that in 2004?
Give a very brief answer. 1.27. What is the ratio of the Savings(% of GNI) of El Salvador in 2001 to that in 2004?
Provide a succinct answer. 1.4. What is the ratio of the Savings(% of GNI) in Mongolia in 2001 to that in 2004?
Make the answer very short. 0.42. What is the ratio of the Savings(% of GNI) of Latin America(developing only) in 2002 to that in 2003?
Keep it short and to the point. 0.9. What is the ratio of the Savings(% of GNI) of Bolivia in 2002 to that in 2003?
Make the answer very short. 1.33. What is the ratio of the Savings(% of GNI) of El Salvador in 2002 to that in 2003?
Offer a terse response. 1.15. What is the ratio of the Savings(% of GNI) in Mongolia in 2002 to that in 2003?
Your response must be concise. 0.39. What is the ratio of the Savings(% of GNI) in Latin America(developing only) in 2002 to that in 2004?
Your answer should be very brief. 0.8. What is the ratio of the Savings(% of GNI) of Bolivia in 2002 to that in 2004?
Provide a succinct answer. 1.97. What is the ratio of the Savings(% of GNI) of El Salvador in 2002 to that in 2004?
Your answer should be compact. 1.17. What is the ratio of the Savings(% of GNI) of Mongolia in 2002 to that in 2004?
Provide a short and direct response. 0.3. What is the ratio of the Savings(% of GNI) in Latin America(developing only) in 2003 to that in 2004?
Ensure brevity in your answer.  0.89. What is the ratio of the Savings(% of GNI) in Bolivia in 2003 to that in 2004?
Your answer should be very brief. 1.48. What is the ratio of the Savings(% of GNI) of El Salvador in 2003 to that in 2004?
Make the answer very short. 1.01. What is the ratio of the Savings(% of GNI) of Mongolia in 2003 to that in 2004?
Offer a terse response. 0.77. What is the difference between the highest and the second highest Savings(% of GNI) in Latin America(developing only)?
Keep it short and to the point. 1. What is the difference between the highest and the second highest Savings(% of GNI) in Bolivia?
Your response must be concise. 2.69. What is the difference between the highest and the second highest Savings(% of GNI) in El Salvador?
Keep it short and to the point. 0.57. What is the difference between the highest and the second highest Savings(% of GNI) in Mongolia?
Offer a very short reply. 3.41. What is the difference between the highest and the lowest Savings(% of GNI) in Latin America(developing only)?
Give a very brief answer. 2.12. What is the difference between the highest and the lowest Savings(% of GNI) of Bolivia?
Provide a succinct answer. 6.43. What is the difference between the highest and the lowest Savings(% of GNI) of El Salvador?
Make the answer very short. 3.81. What is the difference between the highest and the lowest Savings(% of GNI) in Mongolia?
Your answer should be very brief. 12.92. 